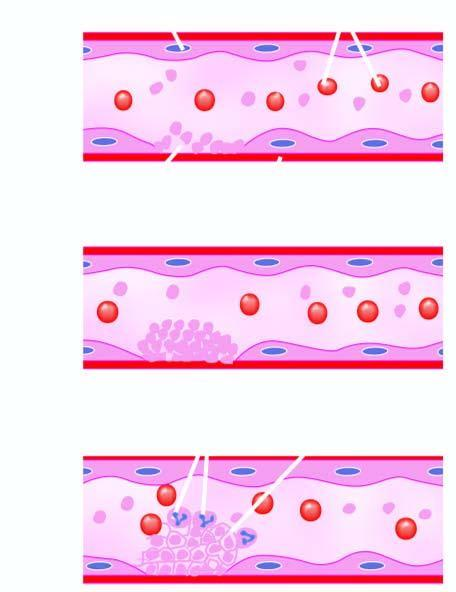does chematic representation of mechanisms expose subendothelium, initiating adherence of platelets and activation of coagulation system?
Answer the question using a single word or phrase. No 